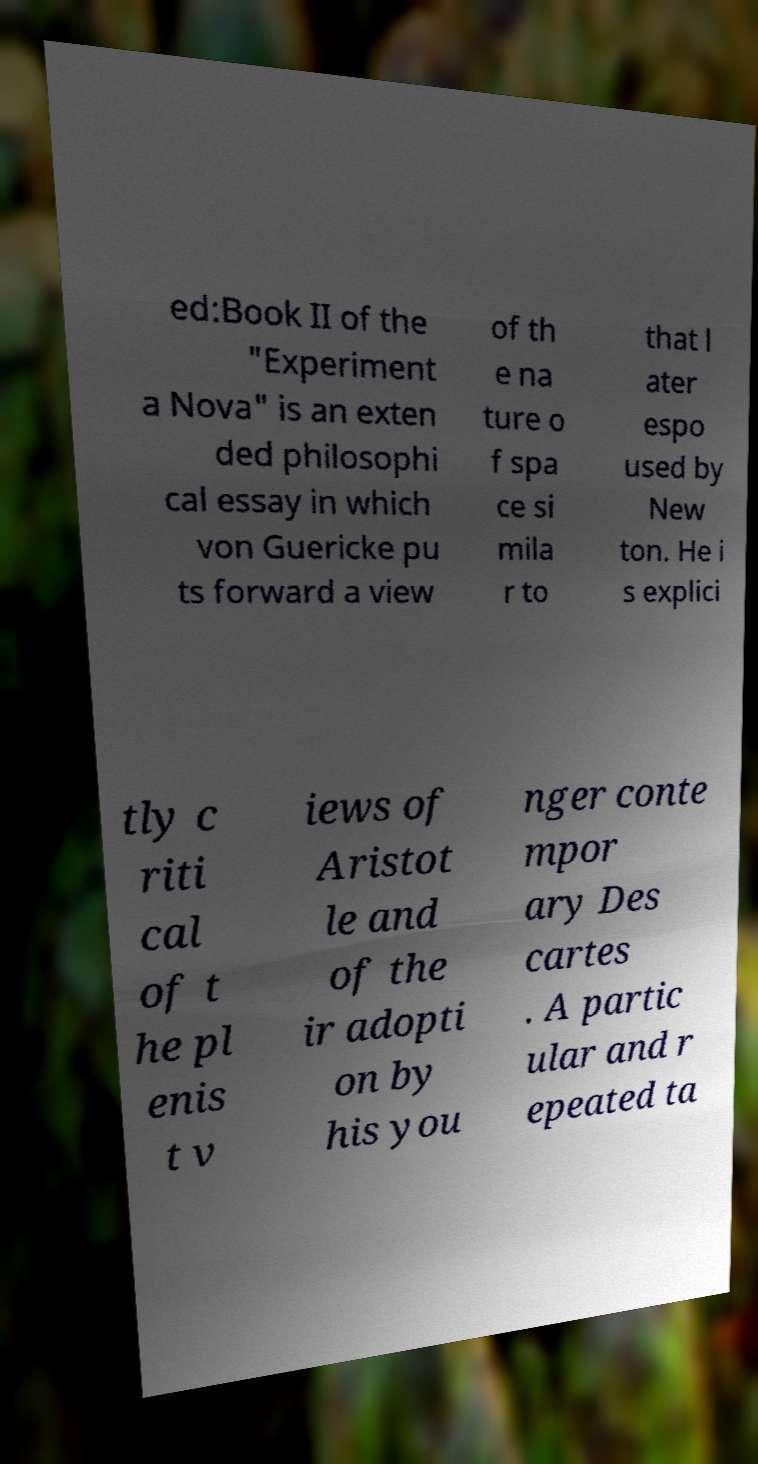I need the written content from this picture converted into text. Can you do that? ed:Book II of the "Experiment a Nova" is an exten ded philosophi cal essay in which von Guericke pu ts forward a view of th e na ture o f spa ce si mila r to that l ater espo used by New ton. He i s explici tly c riti cal of t he pl enis t v iews of Aristot le and of the ir adopti on by his you nger conte mpor ary Des cartes . A partic ular and r epeated ta 